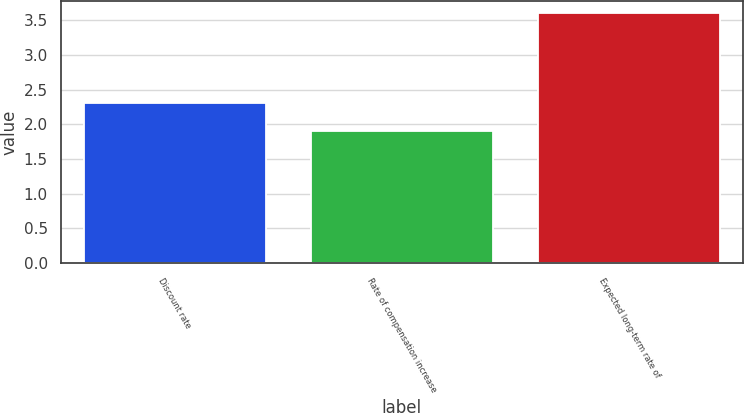<chart> <loc_0><loc_0><loc_500><loc_500><bar_chart><fcel>Discount rate<fcel>Rate of compensation increase<fcel>Expected long-term rate of<nl><fcel>2.3<fcel>1.9<fcel>3.6<nl></chart> 